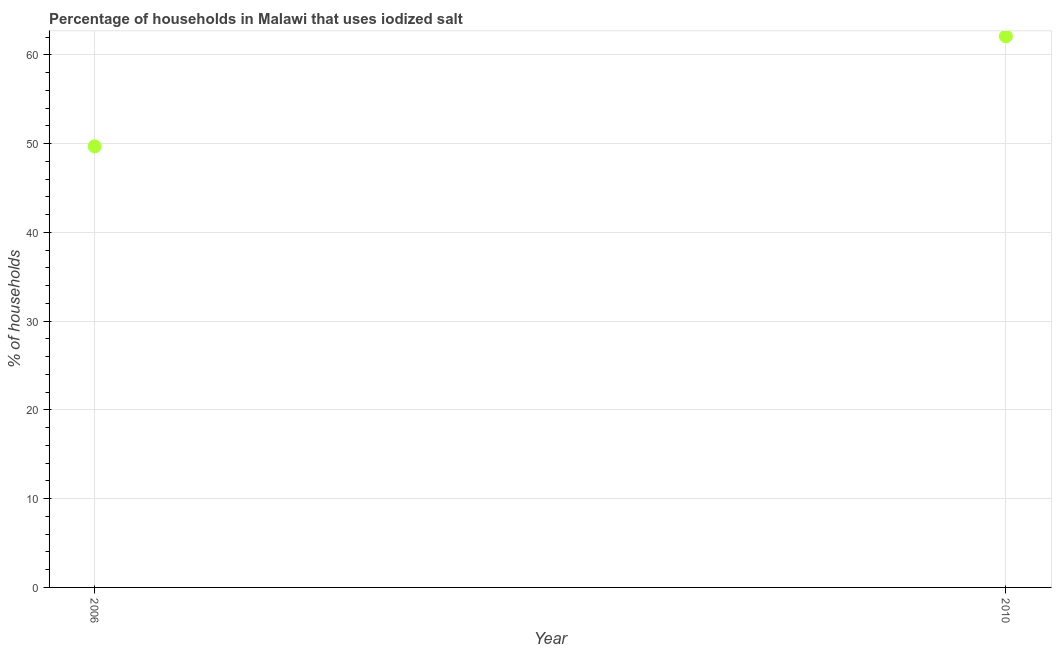What is the percentage of households where iodized salt is consumed in 2010?
Provide a short and direct response. 62.1. Across all years, what is the maximum percentage of households where iodized salt is consumed?
Provide a succinct answer. 62.1. Across all years, what is the minimum percentage of households where iodized salt is consumed?
Your response must be concise. 49.7. In which year was the percentage of households where iodized salt is consumed minimum?
Make the answer very short. 2006. What is the sum of the percentage of households where iodized salt is consumed?
Offer a very short reply. 111.8. What is the difference between the percentage of households where iodized salt is consumed in 2006 and 2010?
Provide a short and direct response. -12.4. What is the average percentage of households where iodized salt is consumed per year?
Offer a terse response. 55.9. What is the median percentage of households where iodized salt is consumed?
Give a very brief answer. 55.9. In how many years, is the percentage of households where iodized salt is consumed greater than 14 %?
Your answer should be compact. 2. What is the ratio of the percentage of households where iodized salt is consumed in 2006 to that in 2010?
Keep it short and to the point. 0.8. Is the percentage of households where iodized salt is consumed in 2006 less than that in 2010?
Your answer should be compact. Yes. In how many years, is the percentage of households where iodized salt is consumed greater than the average percentage of households where iodized salt is consumed taken over all years?
Give a very brief answer. 1. Does the percentage of households where iodized salt is consumed monotonically increase over the years?
Ensure brevity in your answer.  Yes. How many dotlines are there?
Your answer should be compact. 1. Are the values on the major ticks of Y-axis written in scientific E-notation?
Provide a succinct answer. No. Does the graph contain any zero values?
Your answer should be compact. No. Does the graph contain grids?
Offer a very short reply. Yes. What is the title of the graph?
Your answer should be very brief. Percentage of households in Malawi that uses iodized salt. What is the label or title of the Y-axis?
Offer a terse response. % of households. What is the % of households in 2006?
Give a very brief answer. 49.7. What is the % of households in 2010?
Offer a very short reply. 62.1. What is the difference between the % of households in 2006 and 2010?
Offer a terse response. -12.4. 